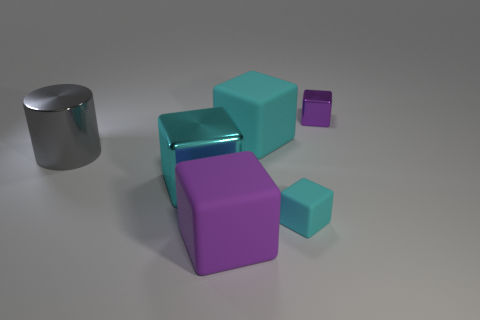There is a tiny cyan object; what shape is it?
Make the answer very short. Cube. How many big objects are cyan cubes or shiny cylinders?
Make the answer very short. 3. There is another cyan rubber thing that is the same shape as the tiny cyan thing; what size is it?
Offer a terse response. Large. What number of objects are on the left side of the cyan metal block and on the right side of the big cylinder?
Provide a succinct answer. 0. There is a big cyan metal object; is it the same shape as the purple object to the right of the tiny matte thing?
Your answer should be compact. Yes. Is the number of cyan rubber blocks that are in front of the shiny cylinder greater than the number of big cyan matte cylinders?
Ensure brevity in your answer.  Yes. Is the number of things that are on the left side of the cylinder less than the number of big matte cubes?
Keep it short and to the point. Yes. What number of big metallic blocks are the same color as the small rubber cube?
Your answer should be compact. 1. What is the material of the thing that is on the right side of the large cyan matte cube and behind the gray thing?
Provide a short and direct response. Metal. Do the tiny object behind the tiny cyan object and the big rubber object that is on the right side of the purple rubber block have the same color?
Your answer should be very brief. No. 